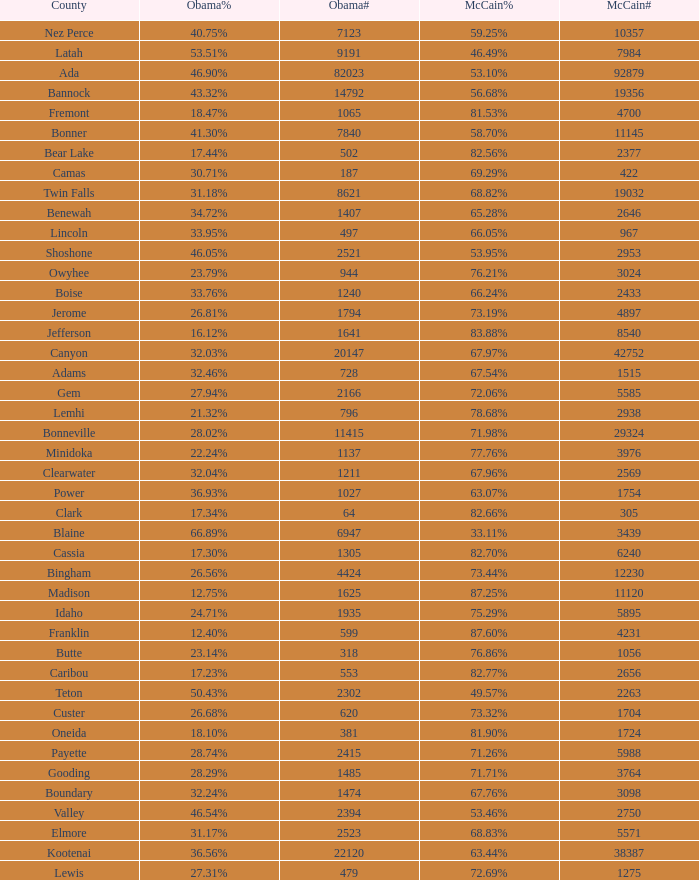What is the maximum McCain population turnout number? 92879.0. 